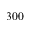<formula> <loc_0><loc_0><loc_500><loc_500>3 0 0</formula> 